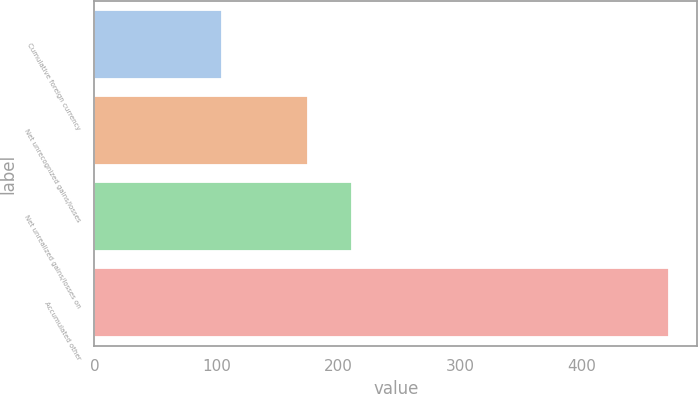<chart> <loc_0><loc_0><loc_500><loc_500><bar_chart><fcel>Cumulative foreign currency<fcel>Net unrecognized gains/losses<fcel>Net unrealized gains/losses on<fcel>Accumulated other<nl><fcel>105<fcel>175<fcel>211.6<fcel>471<nl></chart> 